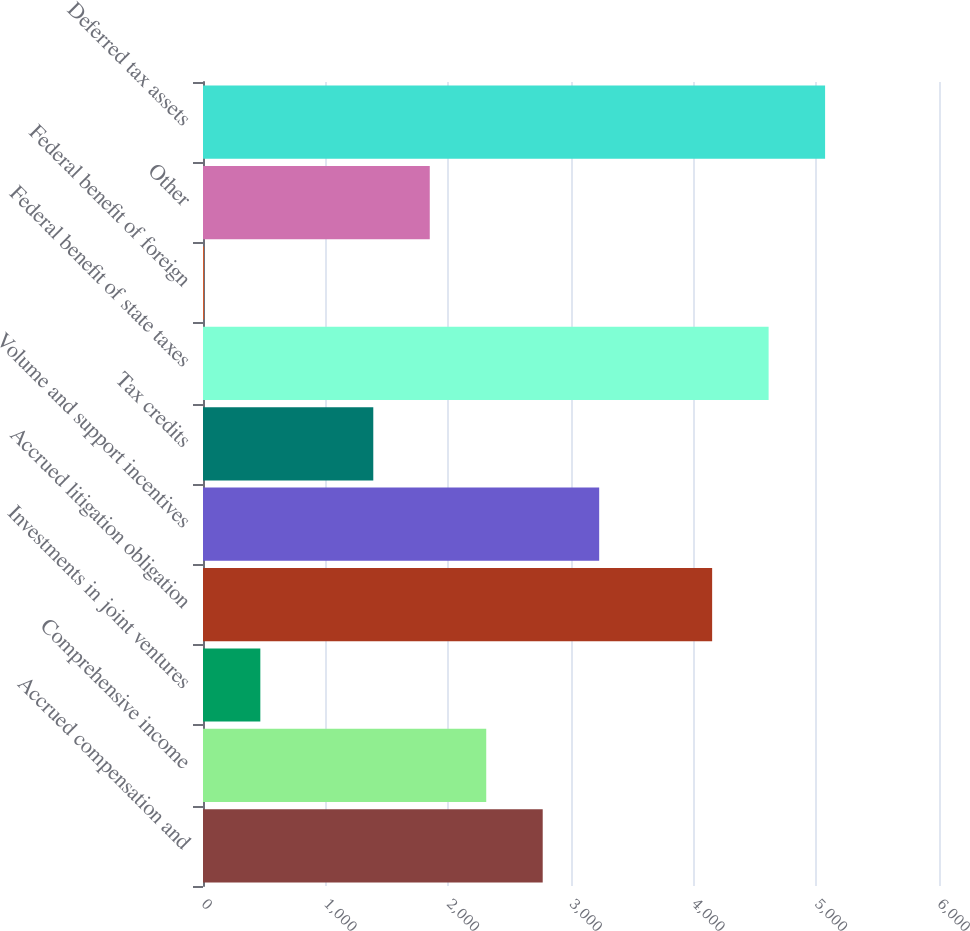Convert chart. <chart><loc_0><loc_0><loc_500><loc_500><bar_chart><fcel>Accrued compensation and<fcel>Comprehensive income<fcel>Investments in joint ventures<fcel>Accrued litigation obligation<fcel>Volume and support incentives<fcel>Tax credits<fcel>Federal benefit of state taxes<fcel>Federal benefit of foreign<fcel>Other<fcel>Deferred tax assets<nl><fcel>2769.4<fcel>2309<fcel>467.4<fcel>4150.6<fcel>3229.8<fcel>1388.2<fcel>4611<fcel>7<fcel>1848.6<fcel>5071.4<nl></chart> 